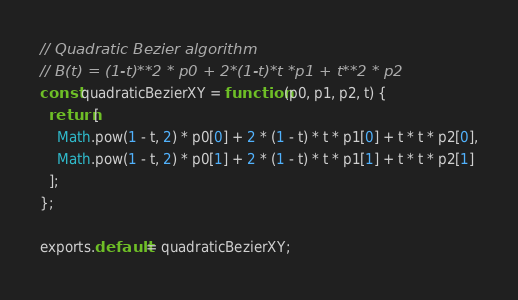<code> <loc_0><loc_0><loc_500><loc_500><_JavaScript_>// Quadratic Bezier algorithm
// B(t) = (1-t)**2 * p0 + 2*(1-t)*t *p1 + t**2 * p2
const quadraticBezierXY = function (p0, p1, p2, t) {
  return [
    Math.pow(1 - t, 2) * p0[0] + 2 * (1 - t) * t * p1[0] + t * t * p2[0],
    Math.pow(1 - t, 2) * p0[1] + 2 * (1 - t) * t * p1[1] + t * t * p2[1]
  ];
};

exports.default = quadraticBezierXY;
</code> 